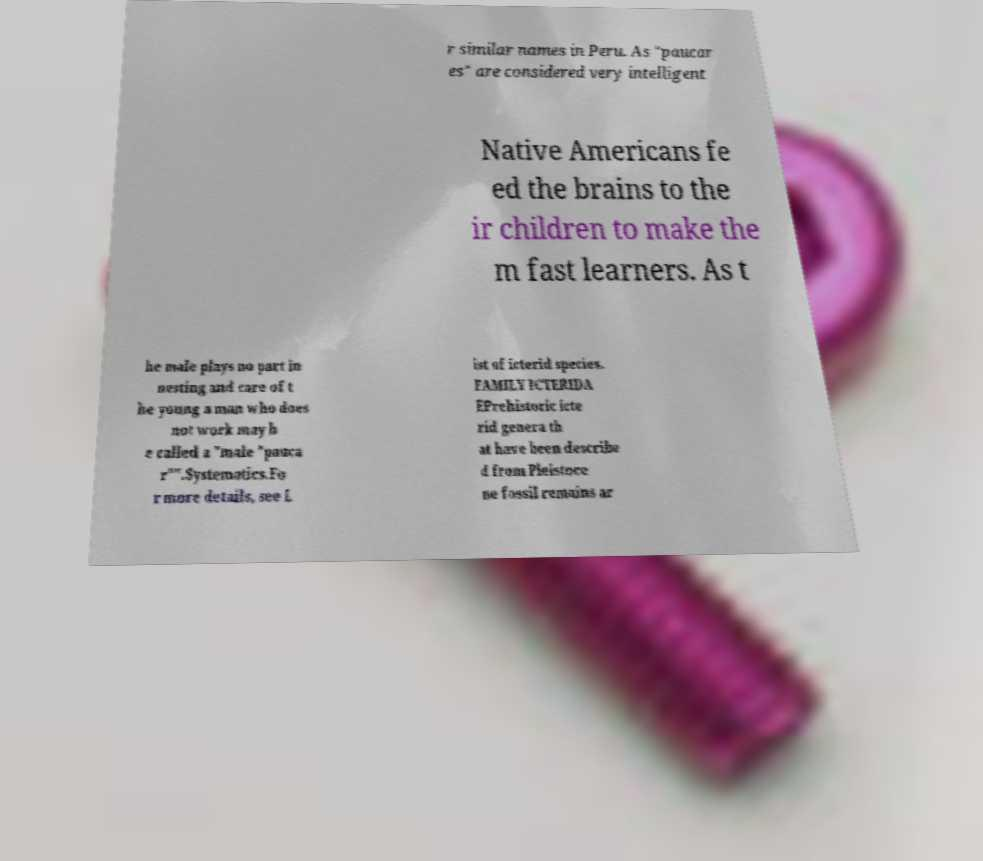Could you extract and type out the text from this image? r similar names in Peru. As "paucar es" are considered very intelligent Native Americans fe ed the brains to the ir children to make the m fast learners. As t he male plays no part in nesting and care of t he young a man who does not work may b e called a "male "pauca r"".Systematics.Fo r more details, see L ist of icterid species. FAMILY ICTERIDA EPrehistoric icte rid genera th at have been describe d from Pleistoce ne fossil remains ar 